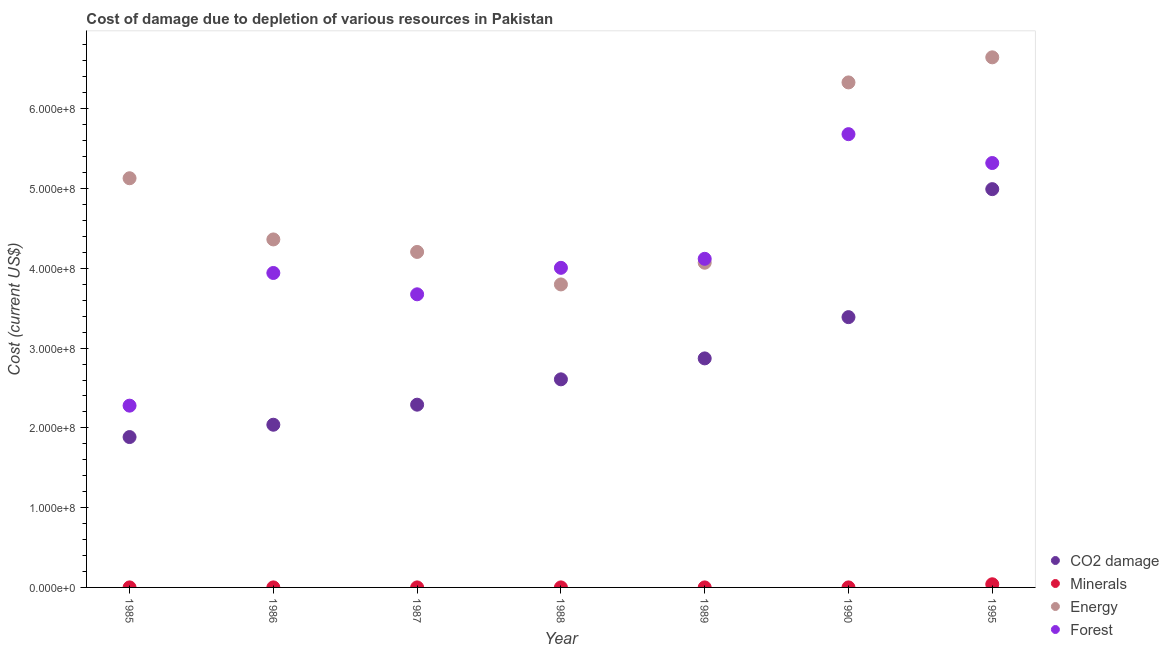How many different coloured dotlines are there?
Ensure brevity in your answer.  4. What is the cost of damage due to depletion of coal in 1989?
Provide a short and direct response. 2.87e+08. Across all years, what is the maximum cost of damage due to depletion of coal?
Ensure brevity in your answer.  4.99e+08. Across all years, what is the minimum cost of damage due to depletion of coal?
Your answer should be very brief. 1.88e+08. In which year was the cost of damage due to depletion of forests maximum?
Your response must be concise. 1990. In which year was the cost of damage due to depletion of energy minimum?
Ensure brevity in your answer.  1988. What is the total cost of damage due to depletion of coal in the graph?
Your answer should be compact. 2.01e+09. What is the difference between the cost of damage due to depletion of coal in 1987 and that in 1990?
Give a very brief answer. -1.10e+08. What is the difference between the cost of damage due to depletion of forests in 1985 and the cost of damage due to depletion of coal in 1986?
Offer a very short reply. 2.39e+07. What is the average cost of damage due to depletion of coal per year?
Provide a succinct answer. 2.87e+08. In the year 1988, what is the difference between the cost of damage due to depletion of energy and cost of damage due to depletion of coal?
Ensure brevity in your answer.  1.19e+08. What is the ratio of the cost of damage due to depletion of coal in 1985 to that in 1995?
Provide a short and direct response. 0.38. Is the cost of damage due to depletion of coal in 1987 less than that in 1990?
Give a very brief answer. Yes. What is the difference between the highest and the second highest cost of damage due to depletion of coal?
Offer a very short reply. 1.60e+08. What is the difference between the highest and the lowest cost of damage due to depletion of minerals?
Make the answer very short. 3.93e+06. In how many years, is the cost of damage due to depletion of energy greater than the average cost of damage due to depletion of energy taken over all years?
Your answer should be very brief. 3. Is the sum of the cost of damage due to depletion of energy in 1986 and 1989 greater than the maximum cost of damage due to depletion of forests across all years?
Give a very brief answer. Yes. Is it the case that in every year, the sum of the cost of damage due to depletion of forests and cost of damage due to depletion of minerals is greater than the sum of cost of damage due to depletion of energy and cost of damage due to depletion of coal?
Keep it short and to the point. Yes. Is the cost of damage due to depletion of energy strictly greater than the cost of damage due to depletion of coal over the years?
Ensure brevity in your answer.  Yes. Is the cost of damage due to depletion of coal strictly less than the cost of damage due to depletion of forests over the years?
Ensure brevity in your answer.  Yes. What is the difference between two consecutive major ticks on the Y-axis?
Provide a succinct answer. 1.00e+08. Does the graph contain grids?
Your answer should be compact. No. Where does the legend appear in the graph?
Provide a short and direct response. Bottom right. How many legend labels are there?
Your answer should be compact. 4. What is the title of the graph?
Offer a terse response. Cost of damage due to depletion of various resources in Pakistan . What is the label or title of the X-axis?
Provide a succinct answer. Year. What is the label or title of the Y-axis?
Make the answer very short. Cost (current US$). What is the Cost (current US$) of CO2 damage in 1985?
Provide a succinct answer. 1.88e+08. What is the Cost (current US$) in Minerals in 1985?
Offer a terse response. 2.56e+04. What is the Cost (current US$) in Energy in 1985?
Keep it short and to the point. 5.13e+08. What is the Cost (current US$) of Forest in 1985?
Provide a succinct answer. 2.28e+08. What is the Cost (current US$) of CO2 damage in 1986?
Offer a terse response. 2.04e+08. What is the Cost (current US$) in Minerals in 1986?
Make the answer very short. 3.43e+04. What is the Cost (current US$) in Energy in 1986?
Your response must be concise. 4.36e+08. What is the Cost (current US$) of Forest in 1986?
Provide a succinct answer. 3.94e+08. What is the Cost (current US$) in CO2 damage in 1987?
Ensure brevity in your answer.  2.29e+08. What is the Cost (current US$) in Minerals in 1987?
Your response must be concise. 2.76e+04. What is the Cost (current US$) of Energy in 1987?
Ensure brevity in your answer.  4.21e+08. What is the Cost (current US$) of Forest in 1987?
Give a very brief answer. 3.67e+08. What is the Cost (current US$) in CO2 damage in 1988?
Offer a terse response. 2.61e+08. What is the Cost (current US$) of Minerals in 1988?
Offer a very short reply. 2.79e+04. What is the Cost (current US$) of Energy in 1988?
Make the answer very short. 3.80e+08. What is the Cost (current US$) of Forest in 1988?
Keep it short and to the point. 4.01e+08. What is the Cost (current US$) of CO2 damage in 1989?
Give a very brief answer. 2.87e+08. What is the Cost (current US$) in Minerals in 1989?
Provide a short and direct response. 2.33e+04. What is the Cost (current US$) in Energy in 1989?
Make the answer very short. 4.07e+08. What is the Cost (current US$) in Forest in 1989?
Give a very brief answer. 4.12e+08. What is the Cost (current US$) of CO2 damage in 1990?
Provide a succinct answer. 3.39e+08. What is the Cost (current US$) of Minerals in 1990?
Make the answer very short. 3.45e+04. What is the Cost (current US$) in Energy in 1990?
Make the answer very short. 6.33e+08. What is the Cost (current US$) in Forest in 1990?
Your response must be concise. 5.68e+08. What is the Cost (current US$) in CO2 damage in 1995?
Your answer should be very brief. 4.99e+08. What is the Cost (current US$) of Minerals in 1995?
Your answer should be very brief. 3.95e+06. What is the Cost (current US$) in Energy in 1995?
Ensure brevity in your answer.  6.64e+08. What is the Cost (current US$) of Forest in 1995?
Make the answer very short. 5.32e+08. Across all years, what is the maximum Cost (current US$) of CO2 damage?
Provide a short and direct response. 4.99e+08. Across all years, what is the maximum Cost (current US$) in Minerals?
Your answer should be compact. 3.95e+06. Across all years, what is the maximum Cost (current US$) of Energy?
Provide a short and direct response. 6.64e+08. Across all years, what is the maximum Cost (current US$) of Forest?
Your response must be concise. 5.68e+08. Across all years, what is the minimum Cost (current US$) in CO2 damage?
Offer a terse response. 1.88e+08. Across all years, what is the minimum Cost (current US$) in Minerals?
Provide a succinct answer. 2.33e+04. Across all years, what is the minimum Cost (current US$) in Energy?
Provide a short and direct response. 3.80e+08. Across all years, what is the minimum Cost (current US$) in Forest?
Keep it short and to the point. 2.28e+08. What is the total Cost (current US$) of CO2 damage in the graph?
Keep it short and to the point. 2.01e+09. What is the total Cost (current US$) in Minerals in the graph?
Offer a terse response. 4.12e+06. What is the total Cost (current US$) of Energy in the graph?
Your answer should be very brief. 3.45e+09. What is the total Cost (current US$) of Forest in the graph?
Your response must be concise. 2.90e+09. What is the difference between the Cost (current US$) in CO2 damage in 1985 and that in 1986?
Ensure brevity in your answer.  -1.55e+07. What is the difference between the Cost (current US$) in Minerals in 1985 and that in 1986?
Provide a succinct answer. -8704.4. What is the difference between the Cost (current US$) in Energy in 1985 and that in 1986?
Ensure brevity in your answer.  7.67e+07. What is the difference between the Cost (current US$) in Forest in 1985 and that in 1986?
Offer a very short reply. -1.66e+08. What is the difference between the Cost (current US$) of CO2 damage in 1985 and that in 1987?
Your answer should be very brief. -4.06e+07. What is the difference between the Cost (current US$) of Minerals in 1985 and that in 1987?
Your response must be concise. -2033.25. What is the difference between the Cost (current US$) in Energy in 1985 and that in 1987?
Your response must be concise. 9.24e+07. What is the difference between the Cost (current US$) in Forest in 1985 and that in 1987?
Ensure brevity in your answer.  -1.40e+08. What is the difference between the Cost (current US$) of CO2 damage in 1985 and that in 1988?
Ensure brevity in your answer.  -7.24e+07. What is the difference between the Cost (current US$) in Minerals in 1985 and that in 1988?
Provide a short and direct response. -2333. What is the difference between the Cost (current US$) of Energy in 1985 and that in 1988?
Provide a succinct answer. 1.33e+08. What is the difference between the Cost (current US$) of Forest in 1985 and that in 1988?
Provide a succinct answer. -1.73e+08. What is the difference between the Cost (current US$) in CO2 damage in 1985 and that in 1989?
Your answer should be compact. -9.86e+07. What is the difference between the Cost (current US$) in Minerals in 1985 and that in 1989?
Provide a short and direct response. 2282.76. What is the difference between the Cost (current US$) in Energy in 1985 and that in 1989?
Keep it short and to the point. 1.06e+08. What is the difference between the Cost (current US$) of Forest in 1985 and that in 1989?
Ensure brevity in your answer.  -1.84e+08. What is the difference between the Cost (current US$) in CO2 damage in 1985 and that in 1990?
Provide a short and direct response. -1.50e+08. What is the difference between the Cost (current US$) of Minerals in 1985 and that in 1990?
Your answer should be compact. -8898.58. What is the difference between the Cost (current US$) in Energy in 1985 and that in 1990?
Give a very brief answer. -1.20e+08. What is the difference between the Cost (current US$) in Forest in 1985 and that in 1990?
Ensure brevity in your answer.  -3.40e+08. What is the difference between the Cost (current US$) of CO2 damage in 1985 and that in 1995?
Your answer should be very brief. -3.11e+08. What is the difference between the Cost (current US$) in Minerals in 1985 and that in 1995?
Provide a short and direct response. -3.93e+06. What is the difference between the Cost (current US$) of Energy in 1985 and that in 1995?
Offer a very short reply. -1.52e+08. What is the difference between the Cost (current US$) of Forest in 1985 and that in 1995?
Offer a very short reply. -3.04e+08. What is the difference between the Cost (current US$) of CO2 damage in 1986 and that in 1987?
Provide a succinct answer. -2.51e+07. What is the difference between the Cost (current US$) in Minerals in 1986 and that in 1987?
Ensure brevity in your answer.  6671.15. What is the difference between the Cost (current US$) of Energy in 1986 and that in 1987?
Your answer should be compact. 1.57e+07. What is the difference between the Cost (current US$) in Forest in 1986 and that in 1987?
Provide a short and direct response. 2.67e+07. What is the difference between the Cost (current US$) in CO2 damage in 1986 and that in 1988?
Your response must be concise. -5.69e+07. What is the difference between the Cost (current US$) in Minerals in 1986 and that in 1988?
Ensure brevity in your answer.  6371.4. What is the difference between the Cost (current US$) in Energy in 1986 and that in 1988?
Offer a terse response. 5.64e+07. What is the difference between the Cost (current US$) of Forest in 1986 and that in 1988?
Provide a short and direct response. -6.44e+06. What is the difference between the Cost (current US$) in CO2 damage in 1986 and that in 1989?
Ensure brevity in your answer.  -8.31e+07. What is the difference between the Cost (current US$) of Minerals in 1986 and that in 1989?
Your answer should be compact. 1.10e+04. What is the difference between the Cost (current US$) in Energy in 1986 and that in 1989?
Offer a terse response. 2.92e+07. What is the difference between the Cost (current US$) of Forest in 1986 and that in 1989?
Make the answer very short. -1.78e+07. What is the difference between the Cost (current US$) in CO2 damage in 1986 and that in 1990?
Keep it short and to the point. -1.35e+08. What is the difference between the Cost (current US$) in Minerals in 1986 and that in 1990?
Your answer should be compact. -194.19. What is the difference between the Cost (current US$) in Energy in 1986 and that in 1990?
Keep it short and to the point. -1.97e+08. What is the difference between the Cost (current US$) in Forest in 1986 and that in 1990?
Your response must be concise. -1.74e+08. What is the difference between the Cost (current US$) in CO2 damage in 1986 and that in 1995?
Your response must be concise. -2.95e+08. What is the difference between the Cost (current US$) of Minerals in 1986 and that in 1995?
Your answer should be compact. -3.92e+06. What is the difference between the Cost (current US$) of Energy in 1986 and that in 1995?
Give a very brief answer. -2.28e+08. What is the difference between the Cost (current US$) in Forest in 1986 and that in 1995?
Provide a succinct answer. -1.38e+08. What is the difference between the Cost (current US$) in CO2 damage in 1987 and that in 1988?
Offer a very short reply. -3.18e+07. What is the difference between the Cost (current US$) of Minerals in 1987 and that in 1988?
Make the answer very short. -299.75. What is the difference between the Cost (current US$) in Energy in 1987 and that in 1988?
Ensure brevity in your answer.  4.07e+07. What is the difference between the Cost (current US$) in Forest in 1987 and that in 1988?
Keep it short and to the point. -3.32e+07. What is the difference between the Cost (current US$) of CO2 damage in 1987 and that in 1989?
Your answer should be compact. -5.80e+07. What is the difference between the Cost (current US$) in Minerals in 1987 and that in 1989?
Your response must be concise. 4316. What is the difference between the Cost (current US$) in Energy in 1987 and that in 1989?
Provide a succinct answer. 1.35e+07. What is the difference between the Cost (current US$) in Forest in 1987 and that in 1989?
Make the answer very short. -4.45e+07. What is the difference between the Cost (current US$) of CO2 damage in 1987 and that in 1990?
Keep it short and to the point. -1.10e+08. What is the difference between the Cost (current US$) of Minerals in 1987 and that in 1990?
Offer a very short reply. -6865.34. What is the difference between the Cost (current US$) of Energy in 1987 and that in 1990?
Ensure brevity in your answer.  -2.12e+08. What is the difference between the Cost (current US$) of Forest in 1987 and that in 1990?
Provide a succinct answer. -2.01e+08. What is the difference between the Cost (current US$) of CO2 damage in 1987 and that in 1995?
Offer a very short reply. -2.70e+08. What is the difference between the Cost (current US$) in Minerals in 1987 and that in 1995?
Provide a short and direct response. -3.92e+06. What is the difference between the Cost (current US$) in Energy in 1987 and that in 1995?
Provide a succinct answer. -2.44e+08. What is the difference between the Cost (current US$) of Forest in 1987 and that in 1995?
Provide a short and direct response. -1.65e+08. What is the difference between the Cost (current US$) of CO2 damage in 1988 and that in 1989?
Your answer should be compact. -2.62e+07. What is the difference between the Cost (current US$) in Minerals in 1988 and that in 1989?
Provide a succinct answer. 4615.75. What is the difference between the Cost (current US$) in Energy in 1988 and that in 1989?
Keep it short and to the point. -2.72e+07. What is the difference between the Cost (current US$) of Forest in 1988 and that in 1989?
Make the answer very short. -1.13e+07. What is the difference between the Cost (current US$) in CO2 damage in 1988 and that in 1990?
Offer a very short reply. -7.80e+07. What is the difference between the Cost (current US$) in Minerals in 1988 and that in 1990?
Your response must be concise. -6565.59. What is the difference between the Cost (current US$) of Energy in 1988 and that in 1990?
Provide a succinct answer. -2.53e+08. What is the difference between the Cost (current US$) of Forest in 1988 and that in 1990?
Offer a terse response. -1.68e+08. What is the difference between the Cost (current US$) in CO2 damage in 1988 and that in 1995?
Give a very brief answer. -2.38e+08. What is the difference between the Cost (current US$) of Minerals in 1988 and that in 1995?
Make the answer very short. -3.92e+06. What is the difference between the Cost (current US$) of Energy in 1988 and that in 1995?
Your response must be concise. -2.85e+08. What is the difference between the Cost (current US$) of Forest in 1988 and that in 1995?
Provide a succinct answer. -1.31e+08. What is the difference between the Cost (current US$) of CO2 damage in 1989 and that in 1990?
Offer a very short reply. -5.17e+07. What is the difference between the Cost (current US$) of Minerals in 1989 and that in 1990?
Offer a very short reply. -1.12e+04. What is the difference between the Cost (current US$) in Energy in 1989 and that in 1990?
Your answer should be compact. -2.26e+08. What is the difference between the Cost (current US$) in Forest in 1989 and that in 1990?
Ensure brevity in your answer.  -1.56e+08. What is the difference between the Cost (current US$) of CO2 damage in 1989 and that in 1995?
Your response must be concise. -2.12e+08. What is the difference between the Cost (current US$) in Minerals in 1989 and that in 1995?
Your answer should be compact. -3.93e+06. What is the difference between the Cost (current US$) of Energy in 1989 and that in 1995?
Offer a very short reply. -2.57e+08. What is the difference between the Cost (current US$) in Forest in 1989 and that in 1995?
Provide a short and direct response. -1.20e+08. What is the difference between the Cost (current US$) of CO2 damage in 1990 and that in 1995?
Give a very brief answer. -1.60e+08. What is the difference between the Cost (current US$) of Minerals in 1990 and that in 1995?
Your answer should be very brief. -3.92e+06. What is the difference between the Cost (current US$) of Energy in 1990 and that in 1995?
Offer a terse response. -3.15e+07. What is the difference between the Cost (current US$) in Forest in 1990 and that in 1995?
Make the answer very short. 3.62e+07. What is the difference between the Cost (current US$) in CO2 damage in 1985 and the Cost (current US$) in Minerals in 1986?
Provide a succinct answer. 1.88e+08. What is the difference between the Cost (current US$) of CO2 damage in 1985 and the Cost (current US$) of Energy in 1986?
Your response must be concise. -2.48e+08. What is the difference between the Cost (current US$) of CO2 damage in 1985 and the Cost (current US$) of Forest in 1986?
Your answer should be very brief. -2.06e+08. What is the difference between the Cost (current US$) in Minerals in 1985 and the Cost (current US$) in Energy in 1986?
Provide a short and direct response. -4.36e+08. What is the difference between the Cost (current US$) of Minerals in 1985 and the Cost (current US$) of Forest in 1986?
Your answer should be very brief. -3.94e+08. What is the difference between the Cost (current US$) in Energy in 1985 and the Cost (current US$) in Forest in 1986?
Your response must be concise. 1.19e+08. What is the difference between the Cost (current US$) in CO2 damage in 1985 and the Cost (current US$) in Minerals in 1987?
Provide a succinct answer. 1.88e+08. What is the difference between the Cost (current US$) in CO2 damage in 1985 and the Cost (current US$) in Energy in 1987?
Offer a terse response. -2.32e+08. What is the difference between the Cost (current US$) in CO2 damage in 1985 and the Cost (current US$) in Forest in 1987?
Give a very brief answer. -1.79e+08. What is the difference between the Cost (current US$) in Minerals in 1985 and the Cost (current US$) in Energy in 1987?
Keep it short and to the point. -4.21e+08. What is the difference between the Cost (current US$) in Minerals in 1985 and the Cost (current US$) in Forest in 1987?
Your response must be concise. -3.67e+08. What is the difference between the Cost (current US$) of Energy in 1985 and the Cost (current US$) of Forest in 1987?
Offer a terse response. 1.45e+08. What is the difference between the Cost (current US$) in CO2 damage in 1985 and the Cost (current US$) in Minerals in 1988?
Make the answer very short. 1.88e+08. What is the difference between the Cost (current US$) of CO2 damage in 1985 and the Cost (current US$) of Energy in 1988?
Ensure brevity in your answer.  -1.91e+08. What is the difference between the Cost (current US$) of CO2 damage in 1985 and the Cost (current US$) of Forest in 1988?
Make the answer very short. -2.12e+08. What is the difference between the Cost (current US$) of Minerals in 1985 and the Cost (current US$) of Energy in 1988?
Give a very brief answer. -3.80e+08. What is the difference between the Cost (current US$) in Minerals in 1985 and the Cost (current US$) in Forest in 1988?
Your answer should be compact. -4.01e+08. What is the difference between the Cost (current US$) in Energy in 1985 and the Cost (current US$) in Forest in 1988?
Make the answer very short. 1.12e+08. What is the difference between the Cost (current US$) of CO2 damage in 1985 and the Cost (current US$) of Minerals in 1989?
Provide a short and direct response. 1.88e+08. What is the difference between the Cost (current US$) in CO2 damage in 1985 and the Cost (current US$) in Energy in 1989?
Offer a very short reply. -2.19e+08. What is the difference between the Cost (current US$) of CO2 damage in 1985 and the Cost (current US$) of Forest in 1989?
Your answer should be very brief. -2.23e+08. What is the difference between the Cost (current US$) in Minerals in 1985 and the Cost (current US$) in Energy in 1989?
Provide a succinct answer. -4.07e+08. What is the difference between the Cost (current US$) of Minerals in 1985 and the Cost (current US$) of Forest in 1989?
Your response must be concise. -4.12e+08. What is the difference between the Cost (current US$) of Energy in 1985 and the Cost (current US$) of Forest in 1989?
Offer a very short reply. 1.01e+08. What is the difference between the Cost (current US$) in CO2 damage in 1985 and the Cost (current US$) in Minerals in 1990?
Make the answer very short. 1.88e+08. What is the difference between the Cost (current US$) of CO2 damage in 1985 and the Cost (current US$) of Energy in 1990?
Ensure brevity in your answer.  -4.45e+08. What is the difference between the Cost (current US$) of CO2 damage in 1985 and the Cost (current US$) of Forest in 1990?
Ensure brevity in your answer.  -3.80e+08. What is the difference between the Cost (current US$) in Minerals in 1985 and the Cost (current US$) in Energy in 1990?
Provide a succinct answer. -6.33e+08. What is the difference between the Cost (current US$) of Minerals in 1985 and the Cost (current US$) of Forest in 1990?
Ensure brevity in your answer.  -5.68e+08. What is the difference between the Cost (current US$) of Energy in 1985 and the Cost (current US$) of Forest in 1990?
Make the answer very short. -5.53e+07. What is the difference between the Cost (current US$) of CO2 damage in 1985 and the Cost (current US$) of Minerals in 1995?
Provide a succinct answer. 1.85e+08. What is the difference between the Cost (current US$) in CO2 damage in 1985 and the Cost (current US$) in Energy in 1995?
Make the answer very short. -4.76e+08. What is the difference between the Cost (current US$) in CO2 damage in 1985 and the Cost (current US$) in Forest in 1995?
Ensure brevity in your answer.  -3.44e+08. What is the difference between the Cost (current US$) in Minerals in 1985 and the Cost (current US$) in Energy in 1995?
Give a very brief answer. -6.64e+08. What is the difference between the Cost (current US$) of Minerals in 1985 and the Cost (current US$) of Forest in 1995?
Your response must be concise. -5.32e+08. What is the difference between the Cost (current US$) of Energy in 1985 and the Cost (current US$) of Forest in 1995?
Offer a very short reply. -1.91e+07. What is the difference between the Cost (current US$) of CO2 damage in 1986 and the Cost (current US$) of Minerals in 1987?
Make the answer very short. 2.04e+08. What is the difference between the Cost (current US$) in CO2 damage in 1986 and the Cost (current US$) in Energy in 1987?
Your answer should be compact. -2.17e+08. What is the difference between the Cost (current US$) in CO2 damage in 1986 and the Cost (current US$) in Forest in 1987?
Provide a succinct answer. -1.63e+08. What is the difference between the Cost (current US$) in Minerals in 1986 and the Cost (current US$) in Energy in 1987?
Your answer should be compact. -4.21e+08. What is the difference between the Cost (current US$) in Minerals in 1986 and the Cost (current US$) in Forest in 1987?
Make the answer very short. -3.67e+08. What is the difference between the Cost (current US$) of Energy in 1986 and the Cost (current US$) of Forest in 1987?
Your answer should be very brief. 6.88e+07. What is the difference between the Cost (current US$) of CO2 damage in 1986 and the Cost (current US$) of Minerals in 1988?
Offer a very short reply. 2.04e+08. What is the difference between the Cost (current US$) of CO2 damage in 1986 and the Cost (current US$) of Energy in 1988?
Offer a very short reply. -1.76e+08. What is the difference between the Cost (current US$) of CO2 damage in 1986 and the Cost (current US$) of Forest in 1988?
Ensure brevity in your answer.  -1.97e+08. What is the difference between the Cost (current US$) in Minerals in 1986 and the Cost (current US$) in Energy in 1988?
Your response must be concise. -3.80e+08. What is the difference between the Cost (current US$) in Minerals in 1986 and the Cost (current US$) in Forest in 1988?
Ensure brevity in your answer.  -4.01e+08. What is the difference between the Cost (current US$) in Energy in 1986 and the Cost (current US$) in Forest in 1988?
Offer a very short reply. 3.56e+07. What is the difference between the Cost (current US$) of CO2 damage in 1986 and the Cost (current US$) of Minerals in 1989?
Make the answer very short. 2.04e+08. What is the difference between the Cost (current US$) in CO2 damage in 1986 and the Cost (current US$) in Energy in 1989?
Provide a succinct answer. -2.03e+08. What is the difference between the Cost (current US$) of CO2 damage in 1986 and the Cost (current US$) of Forest in 1989?
Offer a very short reply. -2.08e+08. What is the difference between the Cost (current US$) of Minerals in 1986 and the Cost (current US$) of Energy in 1989?
Provide a short and direct response. -4.07e+08. What is the difference between the Cost (current US$) of Minerals in 1986 and the Cost (current US$) of Forest in 1989?
Your answer should be compact. -4.12e+08. What is the difference between the Cost (current US$) in Energy in 1986 and the Cost (current US$) in Forest in 1989?
Offer a very short reply. 2.43e+07. What is the difference between the Cost (current US$) of CO2 damage in 1986 and the Cost (current US$) of Minerals in 1990?
Provide a succinct answer. 2.04e+08. What is the difference between the Cost (current US$) in CO2 damage in 1986 and the Cost (current US$) in Energy in 1990?
Keep it short and to the point. -4.29e+08. What is the difference between the Cost (current US$) of CO2 damage in 1986 and the Cost (current US$) of Forest in 1990?
Give a very brief answer. -3.64e+08. What is the difference between the Cost (current US$) in Minerals in 1986 and the Cost (current US$) in Energy in 1990?
Your answer should be very brief. -6.33e+08. What is the difference between the Cost (current US$) in Minerals in 1986 and the Cost (current US$) in Forest in 1990?
Your answer should be very brief. -5.68e+08. What is the difference between the Cost (current US$) in Energy in 1986 and the Cost (current US$) in Forest in 1990?
Offer a terse response. -1.32e+08. What is the difference between the Cost (current US$) of CO2 damage in 1986 and the Cost (current US$) of Minerals in 1995?
Ensure brevity in your answer.  2.00e+08. What is the difference between the Cost (current US$) of CO2 damage in 1986 and the Cost (current US$) of Energy in 1995?
Ensure brevity in your answer.  -4.61e+08. What is the difference between the Cost (current US$) in CO2 damage in 1986 and the Cost (current US$) in Forest in 1995?
Offer a terse response. -3.28e+08. What is the difference between the Cost (current US$) in Minerals in 1986 and the Cost (current US$) in Energy in 1995?
Offer a very short reply. -6.64e+08. What is the difference between the Cost (current US$) in Minerals in 1986 and the Cost (current US$) in Forest in 1995?
Provide a short and direct response. -5.32e+08. What is the difference between the Cost (current US$) in Energy in 1986 and the Cost (current US$) in Forest in 1995?
Offer a very short reply. -9.58e+07. What is the difference between the Cost (current US$) in CO2 damage in 1987 and the Cost (current US$) in Minerals in 1988?
Keep it short and to the point. 2.29e+08. What is the difference between the Cost (current US$) in CO2 damage in 1987 and the Cost (current US$) in Energy in 1988?
Offer a very short reply. -1.51e+08. What is the difference between the Cost (current US$) of CO2 damage in 1987 and the Cost (current US$) of Forest in 1988?
Keep it short and to the point. -1.72e+08. What is the difference between the Cost (current US$) in Minerals in 1987 and the Cost (current US$) in Energy in 1988?
Give a very brief answer. -3.80e+08. What is the difference between the Cost (current US$) in Minerals in 1987 and the Cost (current US$) in Forest in 1988?
Provide a succinct answer. -4.01e+08. What is the difference between the Cost (current US$) of Energy in 1987 and the Cost (current US$) of Forest in 1988?
Give a very brief answer. 1.99e+07. What is the difference between the Cost (current US$) of CO2 damage in 1987 and the Cost (current US$) of Minerals in 1989?
Make the answer very short. 2.29e+08. What is the difference between the Cost (current US$) of CO2 damage in 1987 and the Cost (current US$) of Energy in 1989?
Your response must be concise. -1.78e+08. What is the difference between the Cost (current US$) of CO2 damage in 1987 and the Cost (current US$) of Forest in 1989?
Your response must be concise. -1.83e+08. What is the difference between the Cost (current US$) in Minerals in 1987 and the Cost (current US$) in Energy in 1989?
Offer a very short reply. -4.07e+08. What is the difference between the Cost (current US$) in Minerals in 1987 and the Cost (current US$) in Forest in 1989?
Offer a very short reply. -4.12e+08. What is the difference between the Cost (current US$) in Energy in 1987 and the Cost (current US$) in Forest in 1989?
Offer a very short reply. 8.61e+06. What is the difference between the Cost (current US$) in CO2 damage in 1987 and the Cost (current US$) in Minerals in 1990?
Provide a short and direct response. 2.29e+08. What is the difference between the Cost (current US$) of CO2 damage in 1987 and the Cost (current US$) of Energy in 1990?
Offer a terse response. -4.04e+08. What is the difference between the Cost (current US$) of CO2 damage in 1987 and the Cost (current US$) of Forest in 1990?
Your response must be concise. -3.39e+08. What is the difference between the Cost (current US$) of Minerals in 1987 and the Cost (current US$) of Energy in 1990?
Ensure brevity in your answer.  -6.33e+08. What is the difference between the Cost (current US$) in Minerals in 1987 and the Cost (current US$) in Forest in 1990?
Keep it short and to the point. -5.68e+08. What is the difference between the Cost (current US$) of Energy in 1987 and the Cost (current US$) of Forest in 1990?
Make the answer very short. -1.48e+08. What is the difference between the Cost (current US$) in CO2 damage in 1987 and the Cost (current US$) in Minerals in 1995?
Keep it short and to the point. 2.25e+08. What is the difference between the Cost (current US$) in CO2 damage in 1987 and the Cost (current US$) in Energy in 1995?
Your answer should be very brief. -4.35e+08. What is the difference between the Cost (current US$) of CO2 damage in 1987 and the Cost (current US$) of Forest in 1995?
Give a very brief answer. -3.03e+08. What is the difference between the Cost (current US$) of Minerals in 1987 and the Cost (current US$) of Energy in 1995?
Ensure brevity in your answer.  -6.64e+08. What is the difference between the Cost (current US$) in Minerals in 1987 and the Cost (current US$) in Forest in 1995?
Offer a terse response. -5.32e+08. What is the difference between the Cost (current US$) of Energy in 1987 and the Cost (current US$) of Forest in 1995?
Your answer should be compact. -1.11e+08. What is the difference between the Cost (current US$) in CO2 damage in 1988 and the Cost (current US$) in Minerals in 1989?
Your response must be concise. 2.61e+08. What is the difference between the Cost (current US$) of CO2 damage in 1988 and the Cost (current US$) of Energy in 1989?
Your answer should be very brief. -1.46e+08. What is the difference between the Cost (current US$) of CO2 damage in 1988 and the Cost (current US$) of Forest in 1989?
Your answer should be compact. -1.51e+08. What is the difference between the Cost (current US$) in Minerals in 1988 and the Cost (current US$) in Energy in 1989?
Your answer should be very brief. -4.07e+08. What is the difference between the Cost (current US$) of Minerals in 1988 and the Cost (current US$) of Forest in 1989?
Ensure brevity in your answer.  -4.12e+08. What is the difference between the Cost (current US$) in Energy in 1988 and the Cost (current US$) in Forest in 1989?
Ensure brevity in your answer.  -3.21e+07. What is the difference between the Cost (current US$) in CO2 damage in 1988 and the Cost (current US$) in Minerals in 1990?
Keep it short and to the point. 2.61e+08. What is the difference between the Cost (current US$) in CO2 damage in 1988 and the Cost (current US$) in Energy in 1990?
Give a very brief answer. -3.72e+08. What is the difference between the Cost (current US$) of CO2 damage in 1988 and the Cost (current US$) of Forest in 1990?
Offer a terse response. -3.07e+08. What is the difference between the Cost (current US$) in Minerals in 1988 and the Cost (current US$) in Energy in 1990?
Your response must be concise. -6.33e+08. What is the difference between the Cost (current US$) of Minerals in 1988 and the Cost (current US$) of Forest in 1990?
Offer a very short reply. -5.68e+08. What is the difference between the Cost (current US$) of Energy in 1988 and the Cost (current US$) of Forest in 1990?
Keep it short and to the point. -1.88e+08. What is the difference between the Cost (current US$) of CO2 damage in 1988 and the Cost (current US$) of Minerals in 1995?
Give a very brief answer. 2.57e+08. What is the difference between the Cost (current US$) in CO2 damage in 1988 and the Cost (current US$) in Energy in 1995?
Offer a terse response. -4.04e+08. What is the difference between the Cost (current US$) in CO2 damage in 1988 and the Cost (current US$) in Forest in 1995?
Make the answer very short. -2.71e+08. What is the difference between the Cost (current US$) in Minerals in 1988 and the Cost (current US$) in Energy in 1995?
Provide a succinct answer. -6.64e+08. What is the difference between the Cost (current US$) in Minerals in 1988 and the Cost (current US$) in Forest in 1995?
Offer a terse response. -5.32e+08. What is the difference between the Cost (current US$) in Energy in 1988 and the Cost (current US$) in Forest in 1995?
Provide a succinct answer. -1.52e+08. What is the difference between the Cost (current US$) of CO2 damage in 1989 and the Cost (current US$) of Minerals in 1990?
Make the answer very short. 2.87e+08. What is the difference between the Cost (current US$) of CO2 damage in 1989 and the Cost (current US$) of Energy in 1990?
Provide a succinct answer. -3.46e+08. What is the difference between the Cost (current US$) in CO2 damage in 1989 and the Cost (current US$) in Forest in 1990?
Your answer should be compact. -2.81e+08. What is the difference between the Cost (current US$) of Minerals in 1989 and the Cost (current US$) of Energy in 1990?
Offer a terse response. -6.33e+08. What is the difference between the Cost (current US$) in Minerals in 1989 and the Cost (current US$) in Forest in 1990?
Provide a succinct answer. -5.68e+08. What is the difference between the Cost (current US$) of Energy in 1989 and the Cost (current US$) of Forest in 1990?
Give a very brief answer. -1.61e+08. What is the difference between the Cost (current US$) in CO2 damage in 1989 and the Cost (current US$) in Minerals in 1995?
Keep it short and to the point. 2.83e+08. What is the difference between the Cost (current US$) in CO2 damage in 1989 and the Cost (current US$) in Energy in 1995?
Your answer should be compact. -3.77e+08. What is the difference between the Cost (current US$) of CO2 damage in 1989 and the Cost (current US$) of Forest in 1995?
Ensure brevity in your answer.  -2.45e+08. What is the difference between the Cost (current US$) of Minerals in 1989 and the Cost (current US$) of Energy in 1995?
Your answer should be very brief. -6.64e+08. What is the difference between the Cost (current US$) of Minerals in 1989 and the Cost (current US$) of Forest in 1995?
Your answer should be compact. -5.32e+08. What is the difference between the Cost (current US$) in Energy in 1989 and the Cost (current US$) in Forest in 1995?
Ensure brevity in your answer.  -1.25e+08. What is the difference between the Cost (current US$) in CO2 damage in 1990 and the Cost (current US$) in Minerals in 1995?
Provide a succinct answer. 3.35e+08. What is the difference between the Cost (current US$) of CO2 damage in 1990 and the Cost (current US$) of Energy in 1995?
Give a very brief answer. -3.26e+08. What is the difference between the Cost (current US$) of CO2 damage in 1990 and the Cost (current US$) of Forest in 1995?
Your answer should be very brief. -1.93e+08. What is the difference between the Cost (current US$) of Minerals in 1990 and the Cost (current US$) of Energy in 1995?
Provide a succinct answer. -6.64e+08. What is the difference between the Cost (current US$) in Minerals in 1990 and the Cost (current US$) in Forest in 1995?
Your answer should be very brief. -5.32e+08. What is the difference between the Cost (current US$) in Energy in 1990 and the Cost (current US$) in Forest in 1995?
Offer a very short reply. 1.01e+08. What is the average Cost (current US$) of CO2 damage per year?
Offer a very short reply. 2.87e+08. What is the average Cost (current US$) in Minerals per year?
Provide a short and direct response. 5.89e+05. What is the average Cost (current US$) of Energy per year?
Keep it short and to the point. 4.93e+08. What is the average Cost (current US$) in Forest per year?
Keep it short and to the point. 4.15e+08. In the year 1985, what is the difference between the Cost (current US$) of CO2 damage and Cost (current US$) of Minerals?
Offer a terse response. 1.88e+08. In the year 1985, what is the difference between the Cost (current US$) of CO2 damage and Cost (current US$) of Energy?
Give a very brief answer. -3.24e+08. In the year 1985, what is the difference between the Cost (current US$) of CO2 damage and Cost (current US$) of Forest?
Make the answer very short. -3.94e+07. In the year 1985, what is the difference between the Cost (current US$) in Minerals and Cost (current US$) in Energy?
Give a very brief answer. -5.13e+08. In the year 1985, what is the difference between the Cost (current US$) of Minerals and Cost (current US$) of Forest?
Provide a succinct answer. -2.28e+08. In the year 1985, what is the difference between the Cost (current US$) in Energy and Cost (current US$) in Forest?
Offer a terse response. 2.85e+08. In the year 1986, what is the difference between the Cost (current US$) of CO2 damage and Cost (current US$) of Minerals?
Provide a succinct answer. 2.04e+08. In the year 1986, what is the difference between the Cost (current US$) of CO2 damage and Cost (current US$) of Energy?
Keep it short and to the point. -2.32e+08. In the year 1986, what is the difference between the Cost (current US$) in CO2 damage and Cost (current US$) in Forest?
Provide a succinct answer. -1.90e+08. In the year 1986, what is the difference between the Cost (current US$) of Minerals and Cost (current US$) of Energy?
Your answer should be very brief. -4.36e+08. In the year 1986, what is the difference between the Cost (current US$) in Minerals and Cost (current US$) in Forest?
Make the answer very short. -3.94e+08. In the year 1986, what is the difference between the Cost (current US$) in Energy and Cost (current US$) in Forest?
Offer a very short reply. 4.20e+07. In the year 1987, what is the difference between the Cost (current US$) in CO2 damage and Cost (current US$) in Minerals?
Make the answer very short. 2.29e+08. In the year 1987, what is the difference between the Cost (current US$) in CO2 damage and Cost (current US$) in Energy?
Your answer should be compact. -1.91e+08. In the year 1987, what is the difference between the Cost (current US$) in CO2 damage and Cost (current US$) in Forest?
Offer a terse response. -1.38e+08. In the year 1987, what is the difference between the Cost (current US$) of Minerals and Cost (current US$) of Energy?
Your response must be concise. -4.21e+08. In the year 1987, what is the difference between the Cost (current US$) in Minerals and Cost (current US$) in Forest?
Keep it short and to the point. -3.67e+08. In the year 1987, what is the difference between the Cost (current US$) in Energy and Cost (current US$) in Forest?
Offer a very short reply. 5.31e+07. In the year 1988, what is the difference between the Cost (current US$) in CO2 damage and Cost (current US$) in Minerals?
Your response must be concise. 2.61e+08. In the year 1988, what is the difference between the Cost (current US$) in CO2 damage and Cost (current US$) in Energy?
Provide a short and direct response. -1.19e+08. In the year 1988, what is the difference between the Cost (current US$) of CO2 damage and Cost (current US$) of Forest?
Give a very brief answer. -1.40e+08. In the year 1988, what is the difference between the Cost (current US$) in Minerals and Cost (current US$) in Energy?
Make the answer very short. -3.80e+08. In the year 1988, what is the difference between the Cost (current US$) of Minerals and Cost (current US$) of Forest?
Keep it short and to the point. -4.01e+08. In the year 1988, what is the difference between the Cost (current US$) of Energy and Cost (current US$) of Forest?
Provide a short and direct response. -2.08e+07. In the year 1989, what is the difference between the Cost (current US$) of CO2 damage and Cost (current US$) of Minerals?
Keep it short and to the point. 2.87e+08. In the year 1989, what is the difference between the Cost (current US$) of CO2 damage and Cost (current US$) of Energy?
Give a very brief answer. -1.20e+08. In the year 1989, what is the difference between the Cost (current US$) in CO2 damage and Cost (current US$) in Forest?
Make the answer very short. -1.25e+08. In the year 1989, what is the difference between the Cost (current US$) of Minerals and Cost (current US$) of Energy?
Keep it short and to the point. -4.07e+08. In the year 1989, what is the difference between the Cost (current US$) of Minerals and Cost (current US$) of Forest?
Provide a succinct answer. -4.12e+08. In the year 1989, what is the difference between the Cost (current US$) in Energy and Cost (current US$) in Forest?
Offer a very short reply. -4.92e+06. In the year 1990, what is the difference between the Cost (current US$) of CO2 damage and Cost (current US$) of Minerals?
Keep it short and to the point. 3.39e+08. In the year 1990, what is the difference between the Cost (current US$) in CO2 damage and Cost (current US$) in Energy?
Give a very brief answer. -2.94e+08. In the year 1990, what is the difference between the Cost (current US$) in CO2 damage and Cost (current US$) in Forest?
Provide a succinct answer. -2.29e+08. In the year 1990, what is the difference between the Cost (current US$) in Minerals and Cost (current US$) in Energy?
Offer a terse response. -6.33e+08. In the year 1990, what is the difference between the Cost (current US$) in Minerals and Cost (current US$) in Forest?
Provide a short and direct response. -5.68e+08. In the year 1990, what is the difference between the Cost (current US$) in Energy and Cost (current US$) in Forest?
Your response must be concise. 6.49e+07. In the year 1995, what is the difference between the Cost (current US$) of CO2 damage and Cost (current US$) of Minerals?
Your answer should be very brief. 4.95e+08. In the year 1995, what is the difference between the Cost (current US$) of CO2 damage and Cost (current US$) of Energy?
Provide a succinct answer. -1.65e+08. In the year 1995, what is the difference between the Cost (current US$) in CO2 damage and Cost (current US$) in Forest?
Your response must be concise. -3.27e+07. In the year 1995, what is the difference between the Cost (current US$) of Minerals and Cost (current US$) of Energy?
Keep it short and to the point. -6.61e+08. In the year 1995, what is the difference between the Cost (current US$) of Minerals and Cost (current US$) of Forest?
Offer a terse response. -5.28e+08. In the year 1995, what is the difference between the Cost (current US$) of Energy and Cost (current US$) of Forest?
Ensure brevity in your answer.  1.32e+08. What is the ratio of the Cost (current US$) of CO2 damage in 1985 to that in 1986?
Provide a short and direct response. 0.92. What is the ratio of the Cost (current US$) of Minerals in 1985 to that in 1986?
Provide a short and direct response. 0.75. What is the ratio of the Cost (current US$) of Energy in 1985 to that in 1986?
Offer a terse response. 1.18. What is the ratio of the Cost (current US$) of Forest in 1985 to that in 1986?
Your response must be concise. 0.58. What is the ratio of the Cost (current US$) of CO2 damage in 1985 to that in 1987?
Your response must be concise. 0.82. What is the ratio of the Cost (current US$) in Minerals in 1985 to that in 1987?
Your answer should be compact. 0.93. What is the ratio of the Cost (current US$) of Energy in 1985 to that in 1987?
Ensure brevity in your answer.  1.22. What is the ratio of the Cost (current US$) of Forest in 1985 to that in 1987?
Ensure brevity in your answer.  0.62. What is the ratio of the Cost (current US$) of CO2 damage in 1985 to that in 1988?
Make the answer very short. 0.72. What is the ratio of the Cost (current US$) in Minerals in 1985 to that in 1988?
Make the answer very short. 0.92. What is the ratio of the Cost (current US$) in Energy in 1985 to that in 1988?
Keep it short and to the point. 1.35. What is the ratio of the Cost (current US$) in Forest in 1985 to that in 1988?
Make the answer very short. 0.57. What is the ratio of the Cost (current US$) of CO2 damage in 1985 to that in 1989?
Give a very brief answer. 0.66. What is the ratio of the Cost (current US$) in Minerals in 1985 to that in 1989?
Provide a succinct answer. 1.1. What is the ratio of the Cost (current US$) of Energy in 1985 to that in 1989?
Keep it short and to the point. 1.26. What is the ratio of the Cost (current US$) of Forest in 1985 to that in 1989?
Your response must be concise. 0.55. What is the ratio of the Cost (current US$) in CO2 damage in 1985 to that in 1990?
Ensure brevity in your answer.  0.56. What is the ratio of the Cost (current US$) in Minerals in 1985 to that in 1990?
Your response must be concise. 0.74. What is the ratio of the Cost (current US$) of Energy in 1985 to that in 1990?
Ensure brevity in your answer.  0.81. What is the ratio of the Cost (current US$) of Forest in 1985 to that in 1990?
Provide a succinct answer. 0.4. What is the ratio of the Cost (current US$) of CO2 damage in 1985 to that in 1995?
Provide a succinct answer. 0.38. What is the ratio of the Cost (current US$) in Minerals in 1985 to that in 1995?
Provide a short and direct response. 0.01. What is the ratio of the Cost (current US$) of Energy in 1985 to that in 1995?
Offer a terse response. 0.77. What is the ratio of the Cost (current US$) in Forest in 1985 to that in 1995?
Provide a short and direct response. 0.43. What is the ratio of the Cost (current US$) of CO2 damage in 1986 to that in 1987?
Ensure brevity in your answer.  0.89. What is the ratio of the Cost (current US$) of Minerals in 1986 to that in 1987?
Give a very brief answer. 1.24. What is the ratio of the Cost (current US$) in Energy in 1986 to that in 1987?
Your answer should be compact. 1.04. What is the ratio of the Cost (current US$) of Forest in 1986 to that in 1987?
Give a very brief answer. 1.07. What is the ratio of the Cost (current US$) in CO2 damage in 1986 to that in 1988?
Provide a short and direct response. 0.78. What is the ratio of the Cost (current US$) of Minerals in 1986 to that in 1988?
Make the answer very short. 1.23. What is the ratio of the Cost (current US$) of Energy in 1986 to that in 1988?
Your answer should be compact. 1.15. What is the ratio of the Cost (current US$) in Forest in 1986 to that in 1988?
Provide a succinct answer. 0.98. What is the ratio of the Cost (current US$) in CO2 damage in 1986 to that in 1989?
Offer a terse response. 0.71. What is the ratio of the Cost (current US$) in Minerals in 1986 to that in 1989?
Your answer should be very brief. 1.47. What is the ratio of the Cost (current US$) in Energy in 1986 to that in 1989?
Provide a succinct answer. 1.07. What is the ratio of the Cost (current US$) of Forest in 1986 to that in 1989?
Offer a terse response. 0.96. What is the ratio of the Cost (current US$) in CO2 damage in 1986 to that in 1990?
Your answer should be very brief. 0.6. What is the ratio of the Cost (current US$) in Energy in 1986 to that in 1990?
Provide a short and direct response. 0.69. What is the ratio of the Cost (current US$) of Forest in 1986 to that in 1990?
Offer a very short reply. 0.69. What is the ratio of the Cost (current US$) in CO2 damage in 1986 to that in 1995?
Provide a short and direct response. 0.41. What is the ratio of the Cost (current US$) of Minerals in 1986 to that in 1995?
Your answer should be very brief. 0.01. What is the ratio of the Cost (current US$) in Energy in 1986 to that in 1995?
Your response must be concise. 0.66. What is the ratio of the Cost (current US$) of Forest in 1986 to that in 1995?
Keep it short and to the point. 0.74. What is the ratio of the Cost (current US$) in CO2 damage in 1987 to that in 1988?
Provide a succinct answer. 0.88. What is the ratio of the Cost (current US$) in Minerals in 1987 to that in 1988?
Your answer should be very brief. 0.99. What is the ratio of the Cost (current US$) of Energy in 1987 to that in 1988?
Make the answer very short. 1.11. What is the ratio of the Cost (current US$) of Forest in 1987 to that in 1988?
Your answer should be very brief. 0.92. What is the ratio of the Cost (current US$) of CO2 damage in 1987 to that in 1989?
Offer a terse response. 0.8. What is the ratio of the Cost (current US$) of Minerals in 1987 to that in 1989?
Offer a very short reply. 1.19. What is the ratio of the Cost (current US$) of Energy in 1987 to that in 1989?
Give a very brief answer. 1.03. What is the ratio of the Cost (current US$) of Forest in 1987 to that in 1989?
Your answer should be very brief. 0.89. What is the ratio of the Cost (current US$) in CO2 damage in 1987 to that in 1990?
Keep it short and to the point. 0.68. What is the ratio of the Cost (current US$) in Minerals in 1987 to that in 1990?
Your answer should be very brief. 0.8. What is the ratio of the Cost (current US$) of Energy in 1987 to that in 1990?
Offer a very short reply. 0.66. What is the ratio of the Cost (current US$) in Forest in 1987 to that in 1990?
Your response must be concise. 0.65. What is the ratio of the Cost (current US$) in CO2 damage in 1987 to that in 1995?
Offer a very short reply. 0.46. What is the ratio of the Cost (current US$) in Minerals in 1987 to that in 1995?
Make the answer very short. 0.01. What is the ratio of the Cost (current US$) in Energy in 1987 to that in 1995?
Your answer should be compact. 0.63. What is the ratio of the Cost (current US$) in Forest in 1987 to that in 1995?
Your response must be concise. 0.69. What is the ratio of the Cost (current US$) of CO2 damage in 1988 to that in 1989?
Your response must be concise. 0.91. What is the ratio of the Cost (current US$) of Minerals in 1988 to that in 1989?
Keep it short and to the point. 1.2. What is the ratio of the Cost (current US$) in Energy in 1988 to that in 1989?
Your response must be concise. 0.93. What is the ratio of the Cost (current US$) of Forest in 1988 to that in 1989?
Offer a terse response. 0.97. What is the ratio of the Cost (current US$) in CO2 damage in 1988 to that in 1990?
Make the answer very short. 0.77. What is the ratio of the Cost (current US$) of Minerals in 1988 to that in 1990?
Give a very brief answer. 0.81. What is the ratio of the Cost (current US$) in Forest in 1988 to that in 1990?
Give a very brief answer. 0.71. What is the ratio of the Cost (current US$) of CO2 damage in 1988 to that in 1995?
Make the answer very short. 0.52. What is the ratio of the Cost (current US$) in Minerals in 1988 to that in 1995?
Make the answer very short. 0.01. What is the ratio of the Cost (current US$) of Energy in 1988 to that in 1995?
Ensure brevity in your answer.  0.57. What is the ratio of the Cost (current US$) in Forest in 1988 to that in 1995?
Your answer should be compact. 0.75. What is the ratio of the Cost (current US$) of CO2 damage in 1989 to that in 1990?
Offer a very short reply. 0.85. What is the ratio of the Cost (current US$) of Minerals in 1989 to that in 1990?
Offer a terse response. 0.68. What is the ratio of the Cost (current US$) of Energy in 1989 to that in 1990?
Your answer should be very brief. 0.64. What is the ratio of the Cost (current US$) in Forest in 1989 to that in 1990?
Offer a very short reply. 0.72. What is the ratio of the Cost (current US$) in CO2 damage in 1989 to that in 1995?
Offer a very short reply. 0.57. What is the ratio of the Cost (current US$) in Minerals in 1989 to that in 1995?
Your answer should be very brief. 0.01. What is the ratio of the Cost (current US$) in Energy in 1989 to that in 1995?
Provide a succinct answer. 0.61. What is the ratio of the Cost (current US$) of Forest in 1989 to that in 1995?
Your answer should be compact. 0.77. What is the ratio of the Cost (current US$) in CO2 damage in 1990 to that in 1995?
Make the answer very short. 0.68. What is the ratio of the Cost (current US$) in Minerals in 1990 to that in 1995?
Your response must be concise. 0.01. What is the ratio of the Cost (current US$) in Energy in 1990 to that in 1995?
Give a very brief answer. 0.95. What is the ratio of the Cost (current US$) in Forest in 1990 to that in 1995?
Give a very brief answer. 1.07. What is the difference between the highest and the second highest Cost (current US$) in CO2 damage?
Offer a very short reply. 1.60e+08. What is the difference between the highest and the second highest Cost (current US$) of Minerals?
Offer a terse response. 3.92e+06. What is the difference between the highest and the second highest Cost (current US$) of Energy?
Ensure brevity in your answer.  3.15e+07. What is the difference between the highest and the second highest Cost (current US$) of Forest?
Make the answer very short. 3.62e+07. What is the difference between the highest and the lowest Cost (current US$) of CO2 damage?
Offer a very short reply. 3.11e+08. What is the difference between the highest and the lowest Cost (current US$) of Minerals?
Your answer should be compact. 3.93e+06. What is the difference between the highest and the lowest Cost (current US$) of Energy?
Make the answer very short. 2.85e+08. What is the difference between the highest and the lowest Cost (current US$) in Forest?
Offer a terse response. 3.40e+08. 